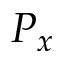<formula> <loc_0><loc_0><loc_500><loc_500>P _ { x }</formula> 